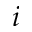<formula> <loc_0><loc_0><loc_500><loc_500>i</formula> 